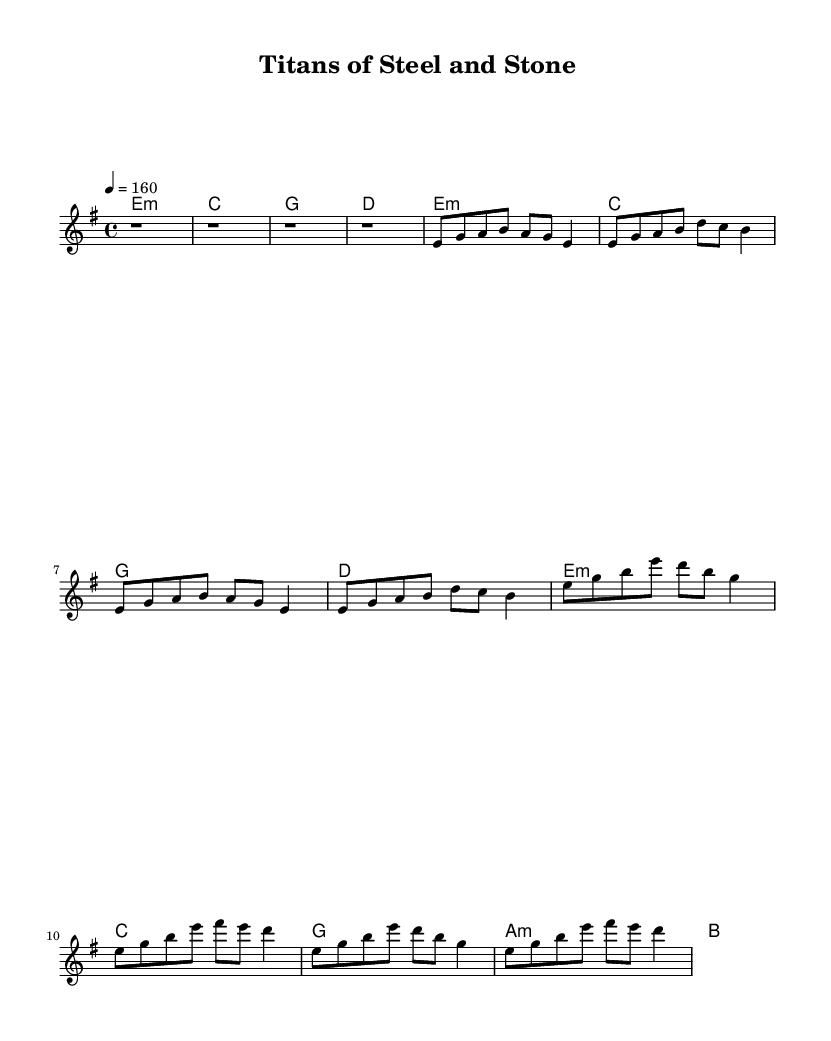What is the key signature of this music? The key signature is E minor, which includes one sharp (F#) and has the relative major of G major. The context clues can be found where the key is specified at the beginning of the piece.
Answer: E minor What is the time signature of the piece? The time signature is 4/4, indicated at the beginning of the score. This means there are four beats in each measure and each quarter note equals one beat.
Answer: 4/4 What is the tempo of the piece? The tempo is set at 160 beats per minute per the tempo marking in the score. This is indicated as a quarter note equals 160, suggesting a fast-paced feel typical of power metal.
Answer: 160 Which section is the opening of the song? The opening section is the 'Intro' which consists of four measures of rest, indicating a build-up to the next part of the song. This is the standard practice in metal to create anticipation.
Answer: Intro How many measures make up the chorus? The chorus contains four measures as presented in the score. The structure is consistent with many anthemic metal songs that employ repetition to drive the energy of the piece.
Answer: 4 What type of harmonies is predominantly used in the chorus? The predominant harmonies used in the chorus are minor and major chords, specifically E minor, C major, G major, and A minor, reflecting the emotional intensity typical in metal music.
Answer: Minor and major Which genre does this music piece belong to? This music piece belongs to the power metal genre, which is characterized by its fast tempos, melodic guitar solos, and often anthemic song structures, emphasizing themes of strength and engineering.
Answer: Power metal 